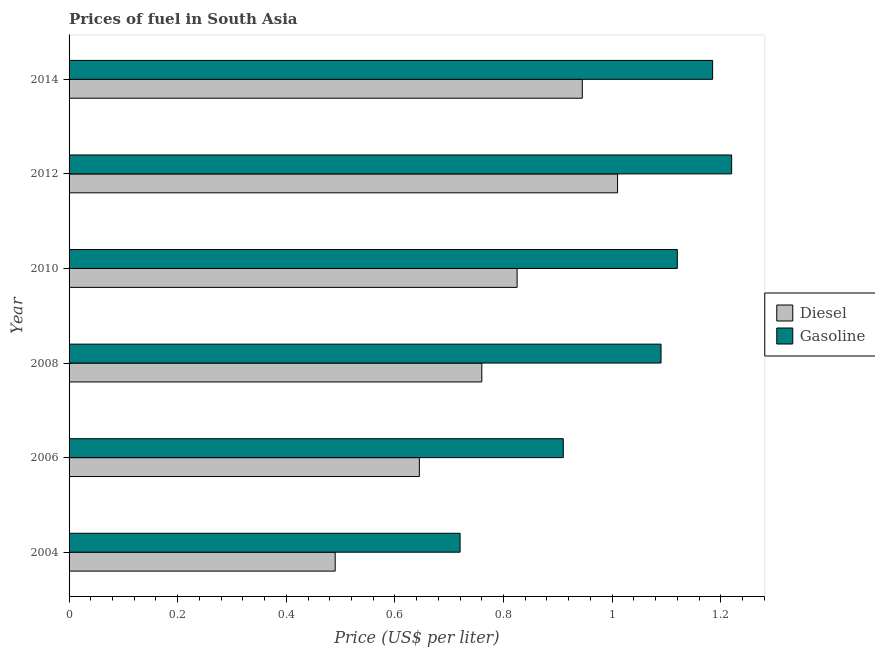How many different coloured bars are there?
Keep it short and to the point. 2. How many groups of bars are there?
Give a very brief answer. 6. How many bars are there on the 2nd tick from the top?
Give a very brief answer. 2. What is the gasoline price in 2014?
Offer a terse response. 1.19. Across all years, what is the maximum gasoline price?
Keep it short and to the point. 1.22. Across all years, what is the minimum diesel price?
Offer a very short reply. 0.49. In which year was the gasoline price maximum?
Keep it short and to the point. 2012. In which year was the diesel price minimum?
Keep it short and to the point. 2004. What is the total gasoline price in the graph?
Your response must be concise. 6.24. What is the difference between the gasoline price in 2004 and that in 2014?
Provide a short and direct response. -0.47. What is the difference between the gasoline price in 2004 and the diesel price in 2014?
Keep it short and to the point. -0.22. What is the average diesel price per year?
Your answer should be compact. 0.78. In the year 2012, what is the difference between the gasoline price and diesel price?
Offer a terse response. 0.21. What is the ratio of the diesel price in 2008 to that in 2014?
Your response must be concise. 0.8. Is the gasoline price in 2010 less than that in 2014?
Your answer should be compact. Yes. What is the difference between the highest and the second highest gasoline price?
Your answer should be very brief. 0.04. In how many years, is the gasoline price greater than the average gasoline price taken over all years?
Offer a very short reply. 4. Is the sum of the diesel price in 2008 and 2010 greater than the maximum gasoline price across all years?
Your response must be concise. Yes. What does the 1st bar from the top in 2014 represents?
Give a very brief answer. Gasoline. What does the 1st bar from the bottom in 2010 represents?
Ensure brevity in your answer.  Diesel. How many bars are there?
Your response must be concise. 12. Are all the bars in the graph horizontal?
Ensure brevity in your answer.  Yes. What is the difference between two consecutive major ticks on the X-axis?
Keep it short and to the point. 0.2. Are the values on the major ticks of X-axis written in scientific E-notation?
Your answer should be compact. No. How are the legend labels stacked?
Provide a short and direct response. Vertical. What is the title of the graph?
Keep it short and to the point. Prices of fuel in South Asia. Does "Education" appear as one of the legend labels in the graph?
Provide a short and direct response. No. What is the label or title of the X-axis?
Offer a terse response. Price (US$ per liter). What is the Price (US$ per liter) of Diesel in 2004?
Offer a very short reply. 0.49. What is the Price (US$ per liter) of Gasoline in 2004?
Provide a short and direct response. 0.72. What is the Price (US$ per liter) of Diesel in 2006?
Offer a terse response. 0.65. What is the Price (US$ per liter) in Gasoline in 2006?
Keep it short and to the point. 0.91. What is the Price (US$ per liter) in Diesel in 2008?
Make the answer very short. 0.76. What is the Price (US$ per liter) in Gasoline in 2008?
Your answer should be very brief. 1.09. What is the Price (US$ per liter) in Diesel in 2010?
Give a very brief answer. 0.82. What is the Price (US$ per liter) in Gasoline in 2010?
Provide a succinct answer. 1.12. What is the Price (US$ per liter) of Gasoline in 2012?
Your answer should be very brief. 1.22. What is the Price (US$ per liter) of Diesel in 2014?
Make the answer very short. 0.94. What is the Price (US$ per liter) in Gasoline in 2014?
Your answer should be very brief. 1.19. Across all years, what is the maximum Price (US$ per liter) of Gasoline?
Your answer should be very brief. 1.22. Across all years, what is the minimum Price (US$ per liter) of Diesel?
Offer a terse response. 0.49. Across all years, what is the minimum Price (US$ per liter) of Gasoline?
Give a very brief answer. 0.72. What is the total Price (US$ per liter) in Diesel in the graph?
Make the answer very short. 4.67. What is the total Price (US$ per liter) in Gasoline in the graph?
Give a very brief answer. 6.25. What is the difference between the Price (US$ per liter) of Diesel in 2004 and that in 2006?
Your answer should be compact. -0.15. What is the difference between the Price (US$ per liter) of Gasoline in 2004 and that in 2006?
Provide a succinct answer. -0.19. What is the difference between the Price (US$ per liter) in Diesel in 2004 and that in 2008?
Give a very brief answer. -0.27. What is the difference between the Price (US$ per liter) of Gasoline in 2004 and that in 2008?
Your answer should be compact. -0.37. What is the difference between the Price (US$ per liter) of Diesel in 2004 and that in 2010?
Your answer should be very brief. -0.34. What is the difference between the Price (US$ per liter) of Diesel in 2004 and that in 2012?
Your response must be concise. -0.52. What is the difference between the Price (US$ per liter) in Gasoline in 2004 and that in 2012?
Your answer should be compact. -0.5. What is the difference between the Price (US$ per liter) in Diesel in 2004 and that in 2014?
Ensure brevity in your answer.  -0.46. What is the difference between the Price (US$ per liter) of Gasoline in 2004 and that in 2014?
Provide a succinct answer. -0.47. What is the difference between the Price (US$ per liter) of Diesel in 2006 and that in 2008?
Provide a short and direct response. -0.12. What is the difference between the Price (US$ per liter) of Gasoline in 2006 and that in 2008?
Your answer should be compact. -0.18. What is the difference between the Price (US$ per liter) in Diesel in 2006 and that in 2010?
Give a very brief answer. -0.18. What is the difference between the Price (US$ per liter) in Gasoline in 2006 and that in 2010?
Ensure brevity in your answer.  -0.21. What is the difference between the Price (US$ per liter) of Diesel in 2006 and that in 2012?
Provide a short and direct response. -0.36. What is the difference between the Price (US$ per liter) of Gasoline in 2006 and that in 2012?
Ensure brevity in your answer.  -0.31. What is the difference between the Price (US$ per liter) of Diesel in 2006 and that in 2014?
Give a very brief answer. -0.3. What is the difference between the Price (US$ per liter) of Gasoline in 2006 and that in 2014?
Provide a short and direct response. -0.28. What is the difference between the Price (US$ per liter) in Diesel in 2008 and that in 2010?
Offer a terse response. -0.07. What is the difference between the Price (US$ per liter) of Gasoline in 2008 and that in 2010?
Provide a short and direct response. -0.03. What is the difference between the Price (US$ per liter) in Gasoline in 2008 and that in 2012?
Provide a succinct answer. -0.13. What is the difference between the Price (US$ per liter) in Diesel in 2008 and that in 2014?
Your answer should be compact. -0.18. What is the difference between the Price (US$ per liter) of Gasoline in 2008 and that in 2014?
Your answer should be compact. -0.1. What is the difference between the Price (US$ per liter) of Diesel in 2010 and that in 2012?
Your answer should be very brief. -0.18. What is the difference between the Price (US$ per liter) in Gasoline in 2010 and that in 2012?
Offer a terse response. -0.1. What is the difference between the Price (US$ per liter) in Diesel in 2010 and that in 2014?
Offer a terse response. -0.12. What is the difference between the Price (US$ per liter) of Gasoline in 2010 and that in 2014?
Provide a short and direct response. -0.07. What is the difference between the Price (US$ per liter) of Diesel in 2012 and that in 2014?
Offer a terse response. 0.07. What is the difference between the Price (US$ per liter) in Gasoline in 2012 and that in 2014?
Keep it short and to the point. 0.04. What is the difference between the Price (US$ per liter) of Diesel in 2004 and the Price (US$ per liter) of Gasoline in 2006?
Your answer should be compact. -0.42. What is the difference between the Price (US$ per liter) of Diesel in 2004 and the Price (US$ per liter) of Gasoline in 2008?
Your answer should be very brief. -0.6. What is the difference between the Price (US$ per liter) in Diesel in 2004 and the Price (US$ per liter) in Gasoline in 2010?
Keep it short and to the point. -0.63. What is the difference between the Price (US$ per liter) of Diesel in 2004 and the Price (US$ per liter) of Gasoline in 2012?
Offer a very short reply. -0.73. What is the difference between the Price (US$ per liter) of Diesel in 2004 and the Price (US$ per liter) of Gasoline in 2014?
Provide a short and direct response. -0.69. What is the difference between the Price (US$ per liter) in Diesel in 2006 and the Price (US$ per liter) in Gasoline in 2008?
Make the answer very short. -0.45. What is the difference between the Price (US$ per liter) in Diesel in 2006 and the Price (US$ per liter) in Gasoline in 2010?
Make the answer very short. -0.47. What is the difference between the Price (US$ per liter) in Diesel in 2006 and the Price (US$ per liter) in Gasoline in 2012?
Ensure brevity in your answer.  -0.57. What is the difference between the Price (US$ per liter) of Diesel in 2006 and the Price (US$ per liter) of Gasoline in 2014?
Provide a succinct answer. -0.54. What is the difference between the Price (US$ per liter) of Diesel in 2008 and the Price (US$ per liter) of Gasoline in 2010?
Your answer should be very brief. -0.36. What is the difference between the Price (US$ per liter) of Diesel in 2008 and the Price (US$ per liter) of Gasoline in 2012?
Your answer should be very brief. -0.46. What is the difference between the Price (US$ per liter) of Diesel in 2008 and the Price (US$ per liter) of Gasoline in 2014?
Make the answer very short. -0.42. What is the difference between the Price (US$ per liter) in Diesel in 2010 and the Price (US$ per liter) in Gasoline in 2012?
Provide a short and direct response. -0.4. What is the difference between the Price (US$ per liter) of Diesel in 2010 and the Price (US$ per liter) of Gasoline in 2014?
Offer a very short reply. -0.36. What is the difference between the Price (US$ per liter) of Diesel in 2012 and the Price (US$ per liter) of Gasoline in 2014?
Keep it short and to the point. -0.17. What is the average Price (US$ per liter) of Diesel per year?
Provide a short and direct response. 0.78. What is the average Price (US$ per liter) in Gasoline per year?
Your answer should be very brief. 1.04. In the year 2004, what is the difference between the Price (US$ per liter) in Diesel and Price (US$ per liter) in Gasoline?
Provide a short and direct response. -0.23. In the year 2006, what is the difference between the Price (US$ per liter) in Diesel and Price (US$ per liter) in Gasoline?
Provide a succinct answer. -0.27. In the year 2008, what is the difference between the Price (US$ per liter) of Diesel and Price (US$ per liter) of Gasoline?
Your answer should be very brief. -0.33. In the year 2010, what is the difference between the Price (US$ per liter) of Diesel and Price (US$ per liter) of Gasoline?
Make the answer very short. -0.29. In the year 2012, what is the difference between the Price (US$ per liter) in Diesel and Price (US$ per liter) in Gasoline?
Your answer should be very brief. -0.21. In the year 2014, what is the difference between the Price (US$ per liter) of Diesel and Price (US$ per liter) of Gasoline?
Offer a terse response. -0.24. What is the ratio of the Price (US$ per liter) in Diesel in 2004 to that in 2006?
Offer a terse response. 0.76. What is the ratio of the Price (US$ per liter) of Gasoline in 2004 to that in 2006?
Make the answer very short. 0.79. What is the ratio of the Price (US$ per liter) of Diesel in 2004 to that in 2008?
Provide a short and direct response. 0.64. What is the ratio of the Price (US$ per liter) of Gasoline in 2004 to that in 2008?
Your response must be concise. 0.66. What is the ratio of the Price (US$ per liter) of Diesel in 2004 to that in 2010?
Your answer should be very brief. 0.59. What is the ratio of the Price (US$ per liter) in Gasoline in 2004 to that in 2010?
Offer a very short reply. 0.64. What is the ratio of the Price (US$ per liter) of Diesel in 2004 to that in 2012?
Provide a succinct answer. 0.49. What is the ratio of the Price (US$ per liter) in Gasoline in 2004 to that in 2012?
Give a very brief answer. 0.59. What is the ratio of the Price (US$ per liter) of Diesel in 2004 to that in 2014?
Your answer should be compact. 0.52. What is the ratio of the Price (US$ per liter) of Gasoline in 2004 to that in 2014?
Keep it short and to the point. 0.61. What is the ratio of the Price (US$ per liter) in Diesel in 2006 to that in 2008?
Offer a terse response. 0.85. What is the ratio of the Price (US$ per liter) in Gasoline in 2006 to that in 2008?
Provide a short and direct response. 0.83. What is the ratio of the Price (US$ per liter) in Diesel in 2006 to that in 2010?
Ensure brevity in your answer.  0.78. What is the ratio of the Price (US$ per liter) of Gasoline in 2006 to that in 2010?
Make the answer very short. 0.81. What is the ratio of the Price (US$ per liter) of Diesel in 2006 to that in 2012?
Provide a short and direct response. 0.64. What is the ratio of the Price (US$ per liter) of Gasoline in 2006 to that in 2012?
Keep it short and to the point. 0.75. What is the ratio of the Price (US$ per liter) in Diesel in 2006 to that in 2014?
Provide a succinct answer. 0.68. What is the ratio of the Price (US$ per liter) in Gasoline in 2006 to that in 2014?
Your response must be concise. 0.77. What is the ratio of the Price (US$ per liter) in Diesel in 2008 to that in 2010?
Provide a short and direct response. 0.92. What is the ratio of the Price (US$ per liter) in Gasoline in 2008 to that in 2010?
Ensure brevity in your answer.  0.97. What is the ratio of the Price (US$ per liter) of Diesel in 2008 to that in 2012?
Ensure brevity in your answer.  0.75. What is the ratio of the Price (US$ per liter) of Gasoline in 2008 to that in 2012?
Give a very brief answer. 0.89. What is the ratio of the Price (US$ per liter) of Diesel in 2008 to that in 2014?
Offer a very short reply. 0.8. What is the ratio of the Price (US$ per liter) of Gasoline in 2008 to that in 2014?
Make the answer very short. 0.92. What is the ratio of the Price (US$ per liter) in Diesel in 2010 to that in 2012?
Keep it short and to the point. 0.82. What is the ratio of the Price (US$ per liter) in Gasoline in 2010 to that in 2012?
Ensure brevity in your answer.  0.92. What is the ratio of the Price (US$ per liter) of Diesel in 2010 to that in 2014?
Provide a short and direct response. 0.87. What is the ratio of the Price (US$ per liter) of Gasoline in 2010 to that in 2014?
Your answer should be compact. 0.95. What is the ratio of the Price (US$ per liter) in Diesel in 2012 to that in 2014?
Provide a succinct answer. 1.07. What is the ratio of the Price (US$ per liter) in Gasoline in 2012 to that in 2014?
Your response must be concise. 1.03. What is the difference between the highest and the second highest Price (US$ per liter) in Diesel?
Make the answer very short. 0.07. What is the difference between the highest and the second highest Price (US$ per liter) in Gasoline?
Provide a short and direct response. 0.04. What is the difference between the highest and the lowest Price (US$ per liter) in Diesel?
Keep it short and to the point. 0.52. What is the difference between the highest and the lowest Price (US$ per liter) in Gasoline?
Offer a very short reply. 0.5. 